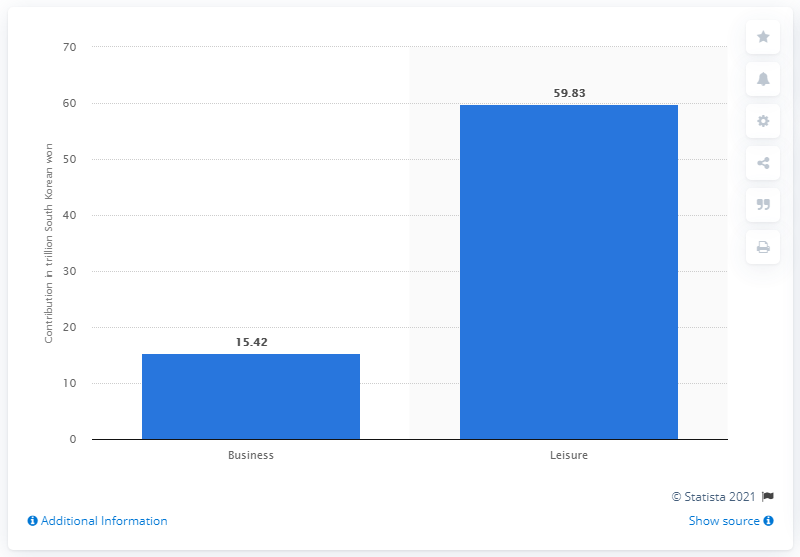Highlight a few significant elements in this photo. In 2017, leisure travel made a significant contribution to South Korea's Gross Domestic Product, accounting for 59.83%. 